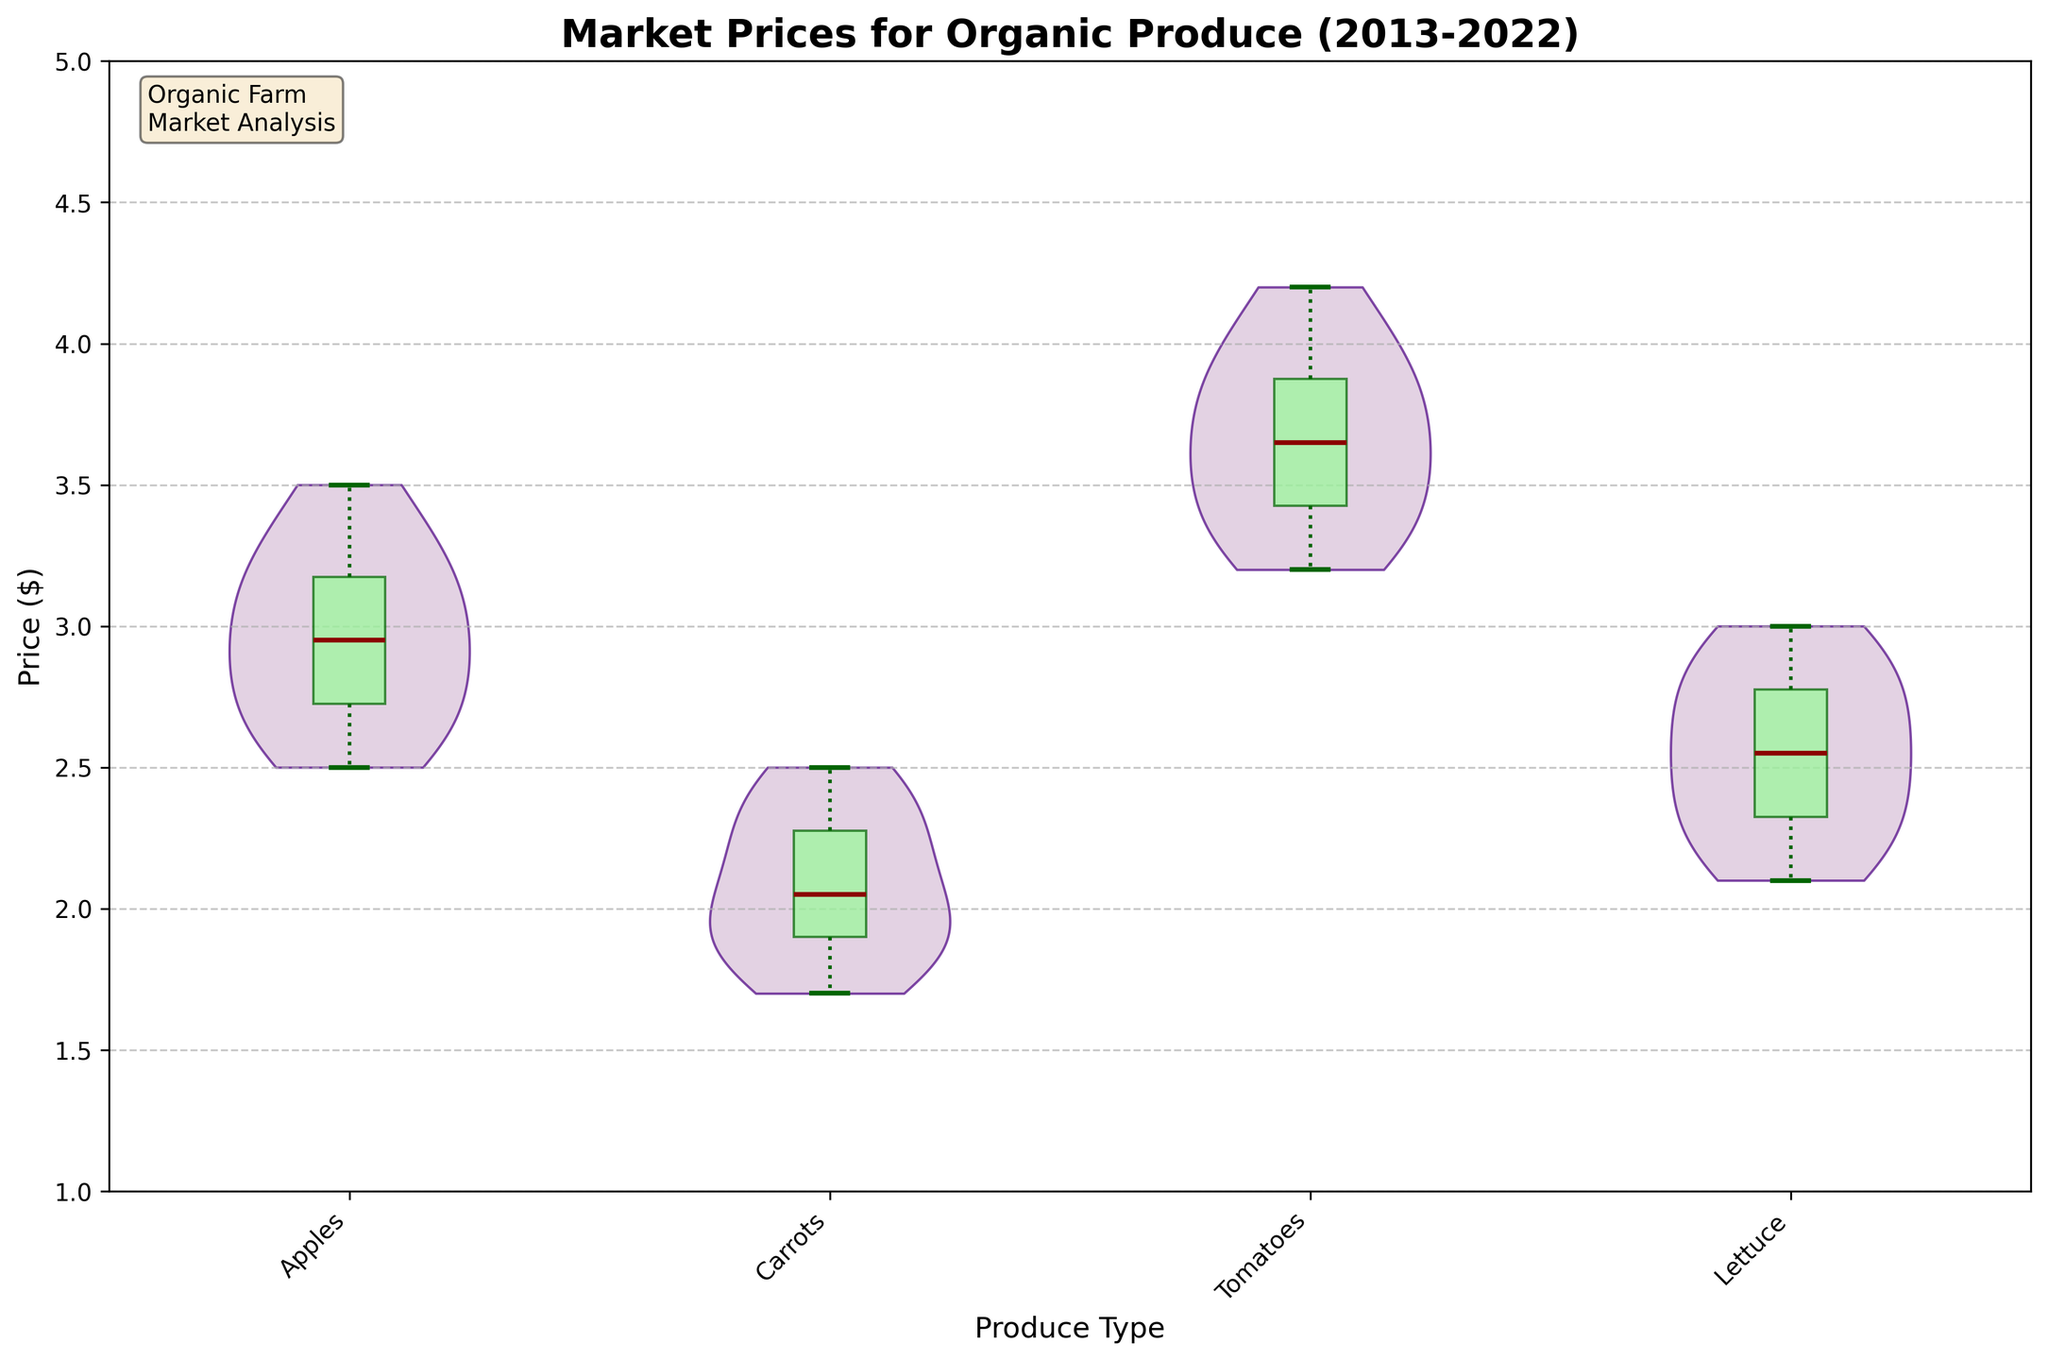What is the title of the figure? The title of the figure is typically found at the top of the plot. It summarizes the content of the chart in a few words. Here, it reads "Market Prices for Organic Produce (2013-2022)."
Answer: Market Prices for Organic Produce (2013-2022) What produce type has the highest median market price? The median market price is indicated by the central horizontal line in each box plot that overlays the violin plots. By comparing these lines, we observe that Tomatoes have the highest median price.
Answer: Tomatoes Which produce type shows the greatest variability in market prices? Variability is depicted by the width of the violin plot and the length of the whiskers in the box plot. By examining these features, Tomatoes display the greatest variability in prices over the years.
Answer: Tomatoes Does any produce type show outliers in the box plot? Outliers in a box plot are typically shown as individual points outside the whiskers, but in this plot, outliers are not displayed as stated in the plot creation. Hence, there are no visible outliers in this figure.
Answer: No What is the average market price range of Carrots? The range is represented by the length of the box and whiskers in the box plot. For Carrots, the range extends from the whisker’s lower end to its upper end, approximately from $1.7 to $2.5.
Answer: 1.7 to 2.5 How does the price of Lettuce change over the observed decade? Observing the progression in the box plot for Lettuce from left to right, we can see an upward trend in prices from around $2.2 in 2013 to approximately $3.0 in 2022.
Answer: Increasing Which produce type experienced the least change in its median price over the years? By comparing the median price lines for each produce type, Carrots show the smallest change in their median prices over the years, indicated by relatively consistent median positions.
Answer: Carrots Are the prices of Apples continuously increasing? By examining the position of the median line in the box plot overlay for Apples, there's a noticeable upward trend year over year indicating that prices are continuously increasing.
Answer: Yes 